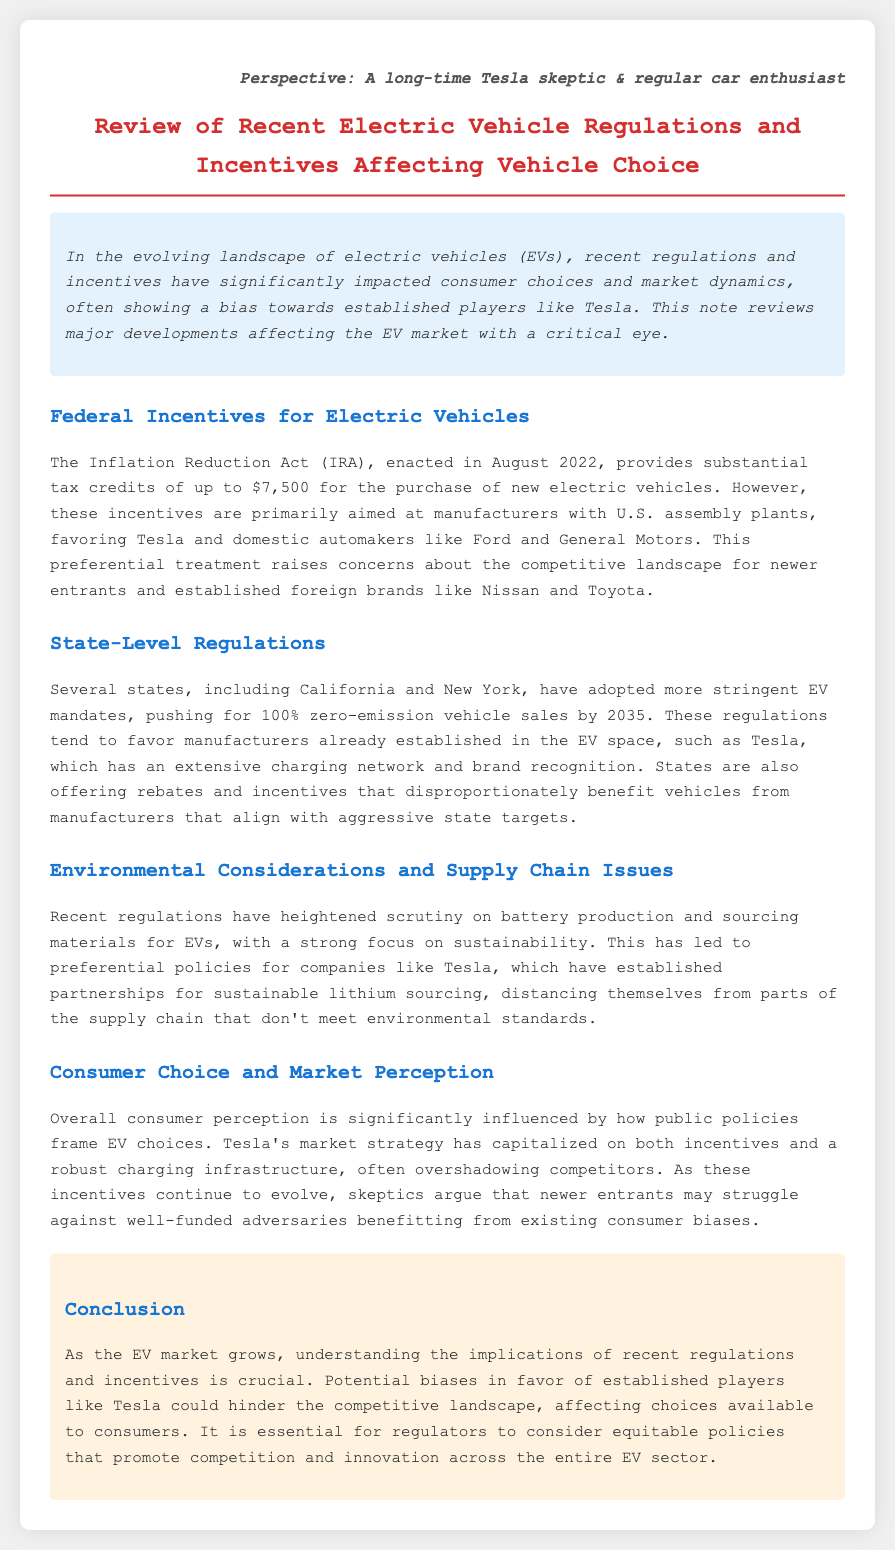What is the main purpose of the document? The document reviews recent regulations and incentives affecting vehicle choices in the EV market, focusing on biases towards Tesla.
Answer: Review of recent electric vehicle regulations and incentives affecting vehicle choice What tax credit amount does the Inflation Reduction Act provide? The document states that the tax credit for the purchase of new electric vehicles under the Inflation Reduction Act is up to $7,500.
Answer: $7,500 Which states have adopted stringent EV mandates? The document specifically mentions California and New York as states that have implemented stringent EV mandates.
Answer: California and New York What year was the Inflation Reduction Act enacted? The document indicates that the Inflation Reduction Act was enacted in August 2022.
Answer: 2022 What is a key concern regarding competitive landscape mentioned in the document? The document raises concerns about the competitive landscape for newer entrants and established foreign brands due to preferential treatment favoring Tesla and domestic automakers.
Answer: Competitive landscape for newer entrants What type of vehicles do several states aim for by 2035? The document notes that several states are pushing for 100% zero-emission vehicle sales by 2035.
Answer: 100% zero-emission vehicle sales How does the document describe Tesla’s market strategy? The document describes Tesla's market strategy as one that has capitalized on incentives and a robust charging infrastructure.
Answer: Capitalized on incentives and robust charging infrastructure What does the document suggest regulators should consider? The document suggests that regulators should consider equitable policies that promote competition and innovation across the entire EV sector.
Answer: Equitable policies that promote competition and innovation 